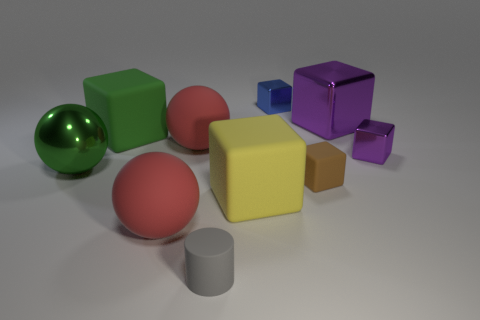Subtract all tiny purple blocks. How many blocks are left? 5 Subtract all green balls. How many balls are left? 2 Subtract all cylinders. How many objects are left? 9 Add 2 cylinders. How many cylinders exist? 3 Subtract 0 green cylinders. How many objects are left? 10 Subtract 1 balls. How many balls are left? 2 Subtract all red cubes. Subtract all blue balls. How many cubes are left? 6 Subtract all gray cylinders. How many cyan balls are left? 0 Subtract all large rubber balls. Subtract all yellow rubber things. How many objects are left? 7 Add 5 red balls. How many red balls are left? 7 